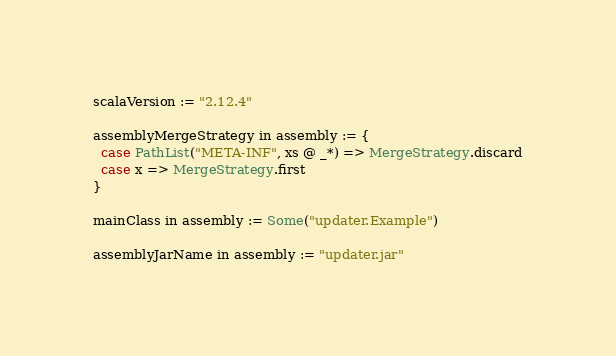<code> <loc_0><loc_0><loc_500><loc_500><_Scala_>
scalaVersion := "2.12.4"

assemblyMergeStrategy in assembly := {
  case PathList("META-INF", xs @ _*) => MergeStrategy.discard
  case x => MergeStrategy.first
}

mainClass in assembly := Some("updater.Example")

assemblyJarName in assembly := "updater.jar"

</code> 